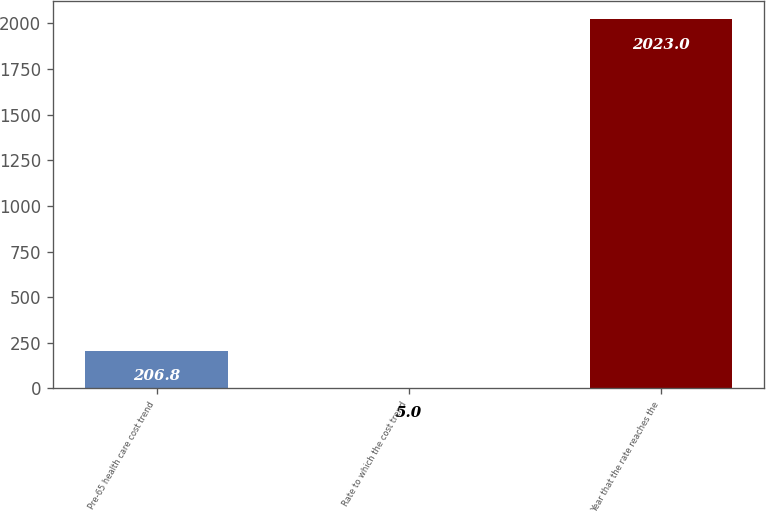Convert chart. <chart><loc_0><loc_0><loc_500><loc_500><bar_chart><fcel>Pre-65 health care cost trend<fcel>Rate to which the cost trend<fcel>Year that the rate reaches the<nl><fcel>206.8<fcel>5<fcel>2023<nl></chart> 